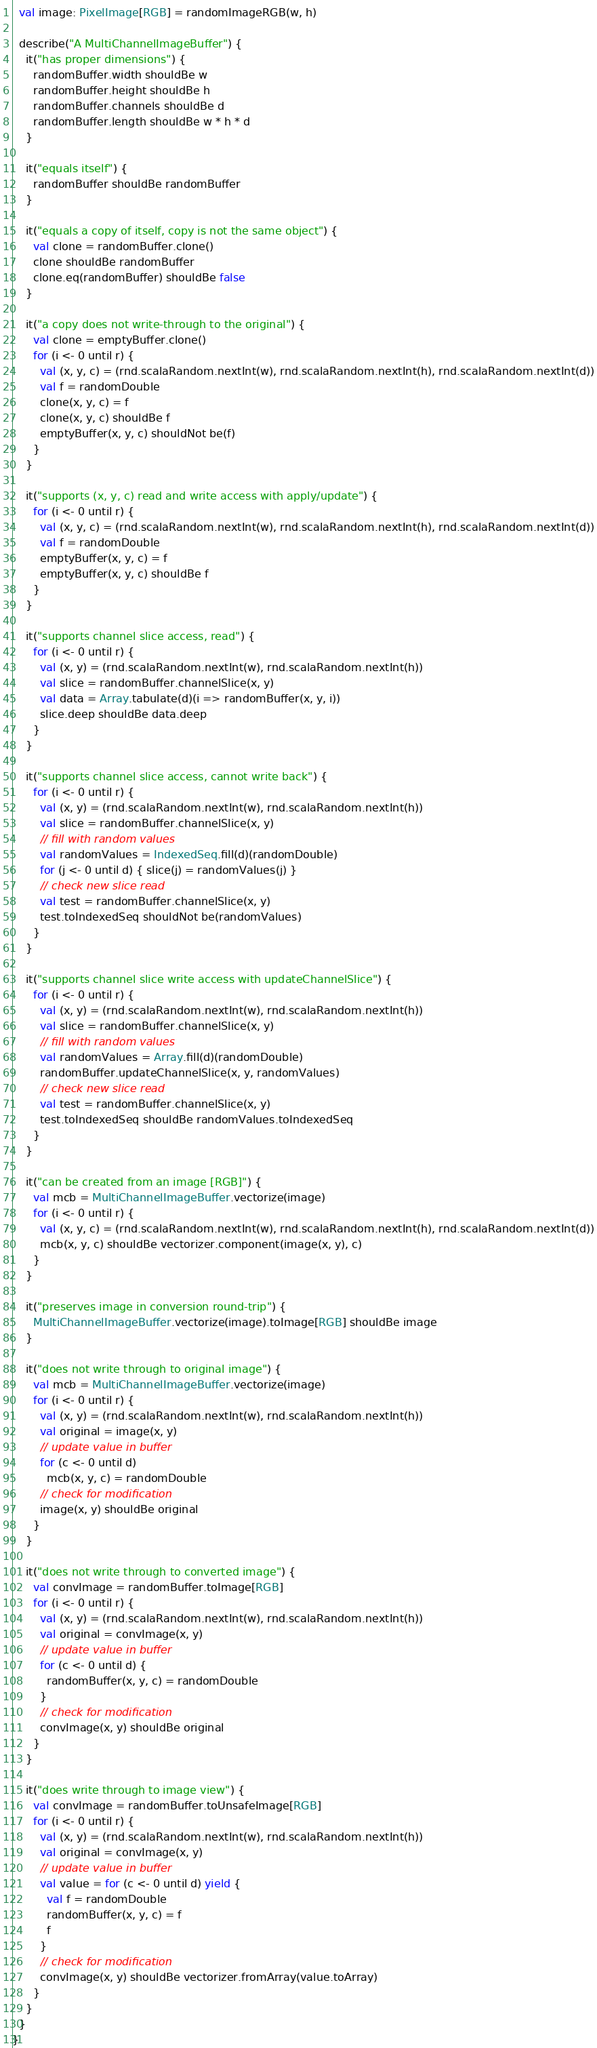<code> <loc_0><loc_0><loc_500><loc_500><_Scala_>
  val image: PixelImage[RGB] = randomImageRGB(w, h)

  describe("A MultiChannelImageBuffer") {
    it("has proper dimensions") {
      randomBuffer.width shouldBe w
      randomBuffer.height shouldBe h
      randomBuffer.channels shouldBe d
      randomBuffer.length shouldBe w * h * d
    }

    it("equals itself") {
      randomBuffer shouldBe randomBuffer
    }

    it("equals a copy of itself, copy is not the same object") {
      val clone = randomBuffer.clone()
      clone shouldBe randomBuffer
      clone.eq(randomBuffer) shouldBe false
    }

    it("a copy does not write-through to the original") {
      val clone = emptyBuffer.clone()
      for (i <- 0 until r) {
        val (x, y, c) = (rnd.scalaRandom.nextInt(w), rnd.scalaRandom.nextInt(h), rnd.scalaRandom.nextInt(d))
        val f = randomDouble
        clone(x, y, c) = f
        clone(x, y, c) shouldBe f
        emptyBuffer(x, y, c) shouldNot be(f)
      }
    }

    it("supports (x, y, c) read and write access with apply/update") {
      for (i <- 0 until r) {
        val (x, y, c) = (rnd.scalaRandom.nextInt(w), rnd.scalaRandom.nextInt(h), rnd.scalaRandom.nextInt(d))
        val f = randomDouble
        emptyBuffer(x, y, c) = f
        emptyBuffer(x, y, c) shouldBe f
      }
    }

    it("supports channel slice access, read") {
      for (i <- 0 until r) {
        val (x, y) = (rnd.scalaRandom.nextInt(w), rnd.scalaRandom.nextInt(h))
        val slice = randomBuffer.channelSlice(x, y)
        val data = Array.tabulate(d)(i => randomBuffer(x, y, i))
        slice.deep shouldBe data.deep
      }
    }

    it("supports channel slice access, cannot write back") {
      for (i <- 0 until r) {
        val (x, y) = (rnd.scalaRandom.nextInt(w), rnd.scalaRandom.nextInt(h))
        val slice = randomBuffer.channelSlice(x, y)
        // fill with random values
        val randomValues = IndexedSeq.fill(d)(randomDouble)
        for (j <- 0 until d) { slice(j) = randomValues(j) }
        // check new slice read
        val test = randomBuffer.channelSlice(x, y)
        test.toIndexedSeq shouldNot be(randomValues)
      }
    }

    it("supports channel slice write access with updateChannelSlice") {
      for (i <- 0 until r) {
        val (x, y) = (rnd.scalaRandom.nextInt(w), rnd.scalaRandom.nextInt(h))
        val slice = randomBuffer.channelSlice(x, y)
        // fill with random values
        val randomValues = Array.fill(d)(randomDouble)
        randomBuffer.updateChannelSlice(x, y, randomValues)
        // check new slice read
        val test = randomBuffer.channelSlice(x, y)
        test.toIndexedSeq shouldBe randomValues.toIndexedSeq
      }
    }

    it("can be created from an image [RGB]") {
      val mcb = MultiChannelImageBuffer.vectorize(image)
      for (i <- 0 until r) {
        val (x, y, c) = (rnd.scalaRandom.nextInt(w), rnd.scalaRandom.nextInt(h), rnd.scalaRandom.nextInt(d))
        mcb(x, y, c) shouldBe vectorizer.component(image(x, y), c)
      }
    }

    it("preserves image in conversion round-trip") {
      MultiChannelImageBuffer.vectorize(image).toImage[RGB] shouldBe image
    }

    it("does not write through to original image") {
      val mcb = MultiChannelImageBuffer.vectorize(image)
      for (i <- 0 until r) {
        val (x, y) = (rnd.scalaRandom.nextInt(w), rnd.scalaRandom.nextInt(h))
        val original = image(x, y)
        // update value in buffer
        for (c <- 0 until d)
          mcb(x, y, c) = randomDouble
        // check for modification
        image(x, y) shouldBe original
      }
    }

    it("does not write through to converted image") {
      val convImage = randomBuffer.toImage[RGB]
      for (i <- 0 until r) {
        val (x, y) = (rnd.scalaRandom.nextInt(w), rnd.scalaRandom.nextInt(h))
        val original = convImage(x, y)
        // update value in buffer
        for (c <- 0 until d) {
          randomBuffer(x, y, c) = randomDouble
        }
        // check for modification
        convImage(x, y) shouldBe original
      }
    }

    it("does write through to image view") {
      val convImage = randomBuffer.toUnsafeImage[RGB]
      for (i <- 0 until r) {
        val (x, y) = (rnd.scalaRandom.nextInt(w), rnd.scalaRandom.nextInt(h))
        val original = convImage(x, y)
        // update value in buffer
        val value = for (c <- 0 until d) yield {
          val f = randomDouble
          randomBuffer(x, y, c) = f
          f
        }
        // check for modification
        convImage(x, y) shouldBe vectorizer.fromArray(value.toArray)
      }
    }
  }
}
</code> 